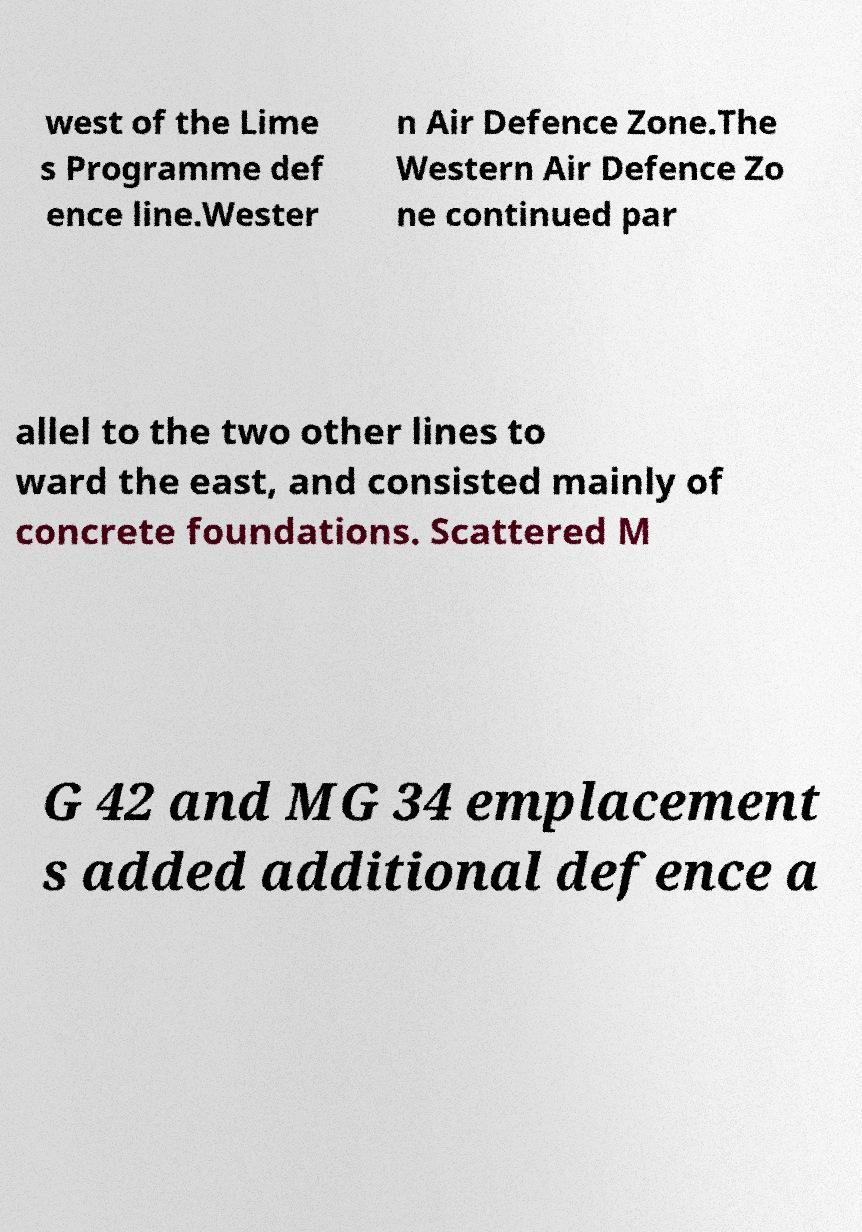Can you accurately transcribe the text from the provided image for me? west of the Lime s Programme def ence line.Wester n Air Defence Zone.The Western Air Defence Zo ne continued par allel to the two other lines to ward the east, and consisted mainly of concrete foundations. Scattered M G 42 and MG 34 emplacement s added additional defence a 